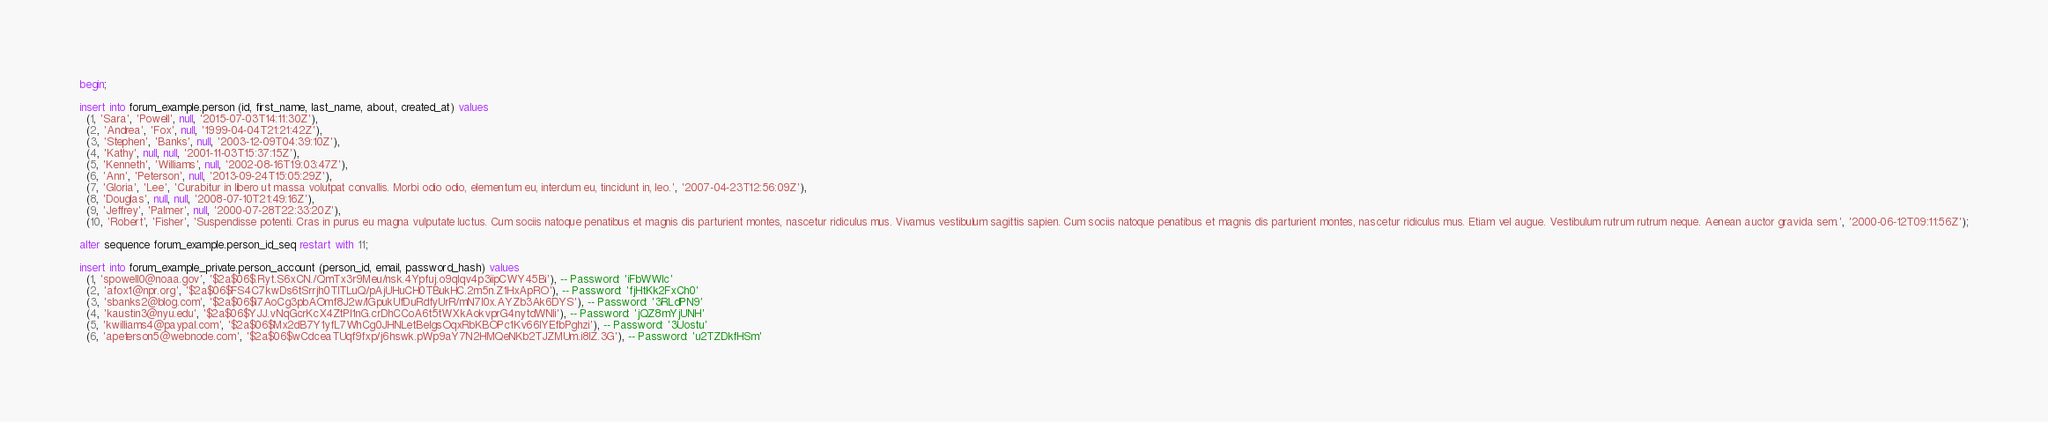<code> <loc_0><loc_0><loc_500><loc_500><_SQL_>begin;

insert into forum_example.person (id, first_name, last_name, about, created_at) values
  (1, 'Sara', 'Powell', null, '2015-07-03T14:11:30Z'),
  (2, 'Andrea', 'Fox', null, '1999-04-04T21:21:42Z'),
  (3, 'Stephen', 'Banks', null, '2003-12-09T04:39:10Z'),
  (4, 'Kathy', null, null, '2001-11-03T15:37:15Z'),
  (5, 'Kenneth', 'Williams', null, '2002-08-16T19:03:47Z'),
  (6, 'Ann', 'Peterson', null, '2013-09-24T15:05:29Z'),
  (7, 'Gloria', 'Lee', 'Curabitur in libero ut massa volutpat convallis. Morbi odio odio, elementum eu, interdum eu, tincidunt in, leo.', '2007-04-23T12:56:09Z'),
  (8, 'Douglas', null, null, '2008-07-10T21:49:16Z'),
  (9, 'Jeffrey', 'Palmer', null, '2000-07-28T22:33:20Z'),
  (10, 'Robert', 'Fisher', 'Suspendisse potenti. Cras in purus eu magna vulputate luctus. Cum sociis natoque penatibus et magnis dis parturient montes, nascetur ridiculus mus. Vivamus vestibulum sagittis sapien. Cum sociis natoque penatibus et magnis dis parturient montes, nascetur ridiculus mus. Etiam vel augue. Vestibulum rutrum rutrum neque. Aenean auctor gravida sem.', '2000-06-12T09:11:56Z');

alter sequence forum_example.person_id_seq restart with 11;

insert into forum_example_private.person_account (person_id, email, password_hash) values
  (1, 'spowell0@noaa.gov', '$2a$06$.Ryt.S6xCN./QmTx3r9Meu/nsk.4Ypfuj.o9qIqv4p3iipCWY45Bi'), -- Password: 'iFbWWlc'
  (2, 'afox1@npr.org', '$2a$06$FS4C7kwDs6tSrrjh0TITLuQ/pAjUHuCH0TBukHC.2m5n.Z1HxApRO'), -- Password: 'fjHtKk2FxCh0'
  (3, 'sbanks2@blog.com', '$2a$06$i7AoCg3pbAOmf8J2w/lGpukUfDuRdfyUrR/mN7I0x.AYZb3Ak6DYS'), -- Password: '3RLdPN9'
  (4, 'kaustin3@nyu.edu', '$2a$06$YJJ.vNqGcrKcX4ZtPl1nG.crDhCCoA6t5tWXkAokvprG4nytdWNli'), -- Password: 'jQZ8mYjUNH'
  (5, 'kwilliams4@paypal.com', '$2a$06$Mx2dB7Y1yfL7WhCg0JHNLetBeIgsOqxRbKBOPc1Kv66lYEfbPghzi'), -- Password: '3Uostu'
  (6, 'apeterson5@webnode.com', '$2a$06$wCdceaTUqf9fxp/j6hswk.pWp9aY7N2HMQeNKb2TJZMUm.i8IZ.3G'), -- Password: 'u2TZDkfHSm'</code> 